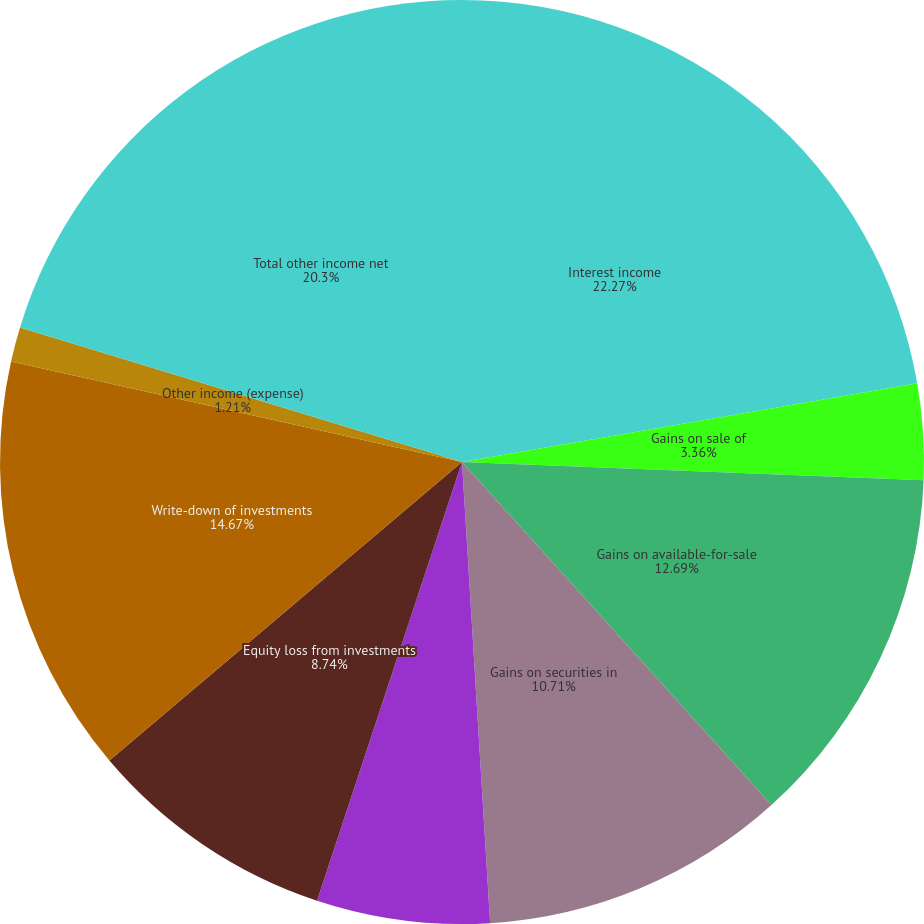Convert chart to OTSL. <chart><loc_0><loc_0><loc_500><loc_500><pie_chart><fcel>Interest income<fcel>Gains on sale of<fcel>Gains on available-for-sale<fcel>Gains on securities in<fcel>Gains (losses) on foreign<fcel>Equity loss from investments<fcel>Write-down of investments<fcel>Other income (expense)<fcel>Total other income net<nl><fcel>22.27%<fcel>3.36%<fcel>12.69%<fcel>10.71%<fcel>6.05%<fcel>8.74%<fcel>14.67%<fcel>1.21%<fcel>20.3%<nl></chart> 